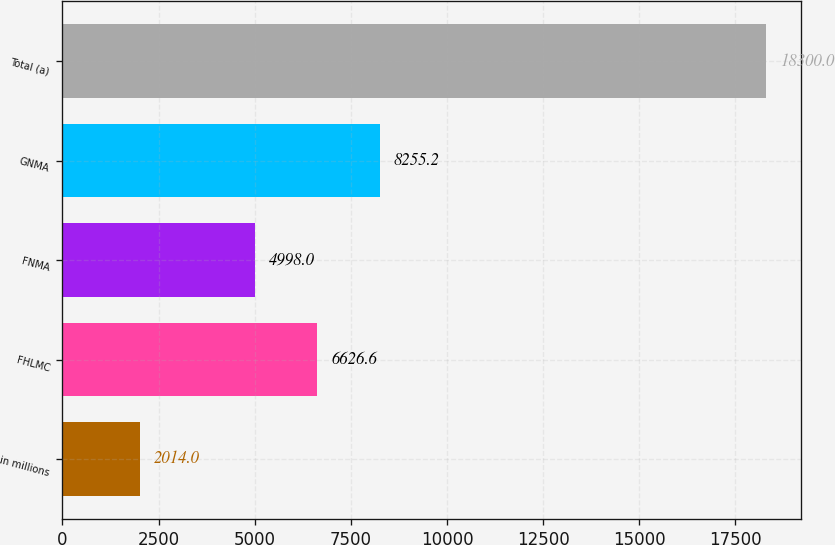Convert chart to OTSL. <chart><loc_0><loc_0><loc_500><loc_500><bar_chart><fcel>in millions<fcel>FHLMC<fcel>FNMA<fcel>GNMA<fcel>Total (a)<nl><fcel>2014<fcel>6626.6<fcel>4998<fcel>8255.2<fcel>18300<nl></chart> 